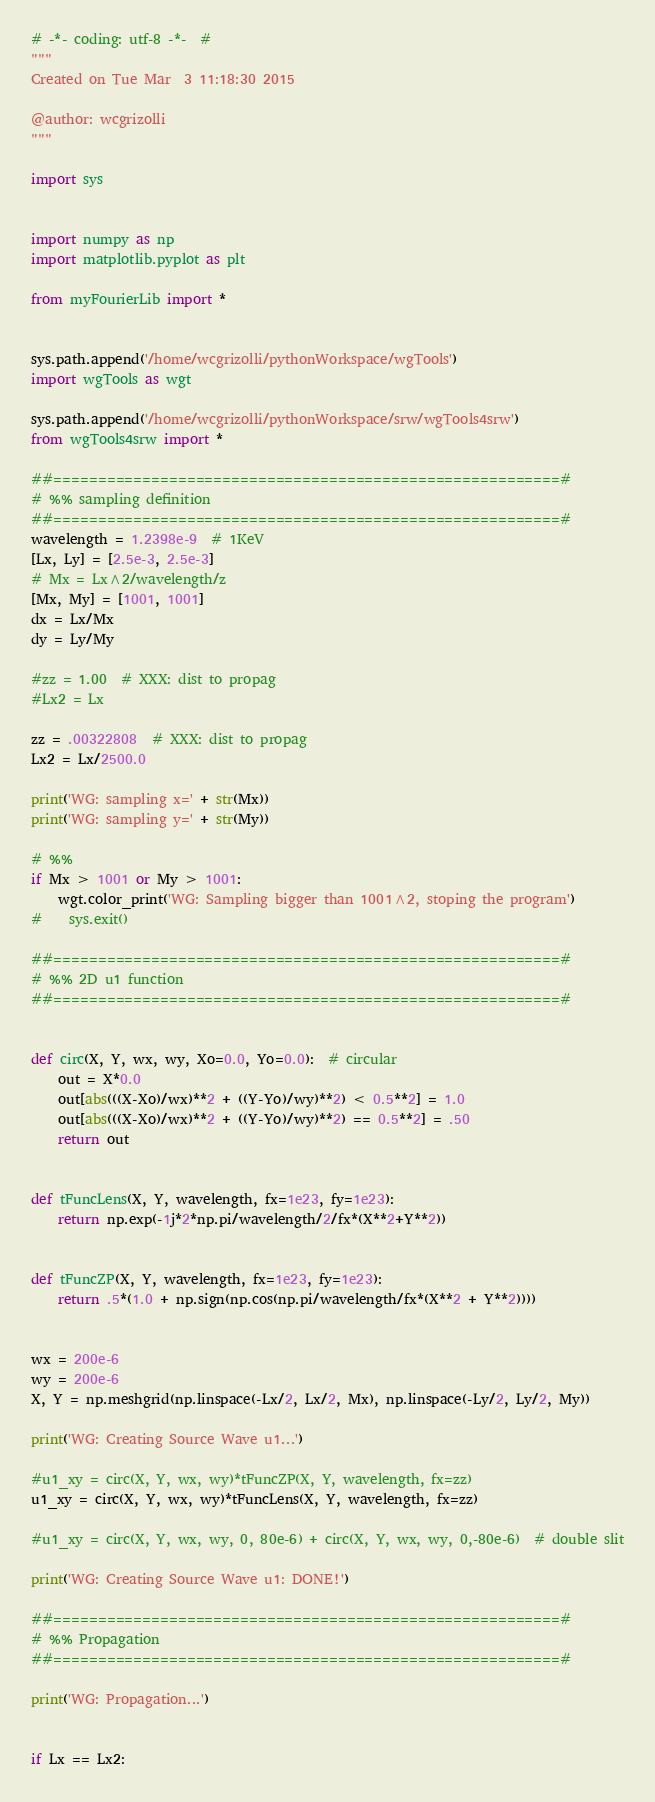<code> <loc_0><loc_0><loc_500><loc_500><_Python_># -*- coding: utf-8 -*-  #
"""
Created on Tue Mar  3 11:18:30 2015

@author: wcgrizolli
"""

import sys


import numpy as np
import matplotlib.pyplot as plt

from myFourierLib import *


sys.path.append('/home/wcgrizolli/pythonWorkspace/wgTools')
import wgTools as wgt

sys.path.append('/home/wcgrizolli/pythonWorkspace/srw/wgTools4srw')
from wgTools4srw import *

##=========================================================#
# %% sampling definition
##=========================================================#
wavelength = 1.2398e-9  # 1KeV
[Lx, Ly] = [2.5e-3, 2.5e-3]
# Mx = Lx^2/wavelength/z
[Mx, My] = [1001, 1001]
dx = Lx/Mx
dy = Ly/My

#zz = 1.00  # XXX: dist to propag
#Lx2 = Lx

zz = .00322808  # XXX: dist to propag
Lx2 = Lx/2500.0

print('WG: sampling x=' + str(Mx))
print('WG: sampling y=' + str(My))

# %%
if Mx > 1001 or My > 1001:
    wgt.color_print('WG: Sampling bigger than 1001^2, stoping the program')
#    sys.exit()

##=========================================================#
# %% 2D u1 function
##=========================================================#


def circ(X, Y, wx, wy, Xo=0.0, Yo=0.0):  # circular
    out = X*0.0
    out[abs(((X-Xo)/wx)**2 + ((Y-Yo)/wy)**2) < 0.5**2] = 1.0
    out[abs(((X-Xo)/wx)**2 + ((Y-Yo)/wy)**2) == 0.5**2] = .50
    return out


def tFuncLens(X, Y, wavelength, fx=1e23, fy=1e23):
    return np.exp(-1j*2*np.pi/wavelength/2/fx*(X**2+Y**2))


def tFuncZP(X, Y, wavelength, fx=1e23, fy=1e23):
    return .5*(1.0 + np.sign(np.cos(np.pi/wavelength/fx*(X**2 + Y**2))))


wx = 200e-6
wy = 200e-6
X, Y = np.meshgrid(np.linspace(-Lx/2, Lx/2, Mx), np.linspace(-Ly/2, Ly/2, My))

print('WG: Creating Source Wave u1...')

#u1_xy = circ(X, Y, wx, wy)*tFuncZP(X, Y, wavelength, fx=zz)
u1_xy = circ(X, Y, wx, wy)*tFuncLens(X, Y, wavelength, fx=zz)

#u1_xy = circ(X, Y, wx, wy, 0, 80e-6) + circ(X, Y, wx, wy, 0,-80e-6)  # double slit

print('WG: Creating Source Wave u1: DONE!')

##=========================================================#
# %% Propagation
##=========================================================#

print('WG: Propagation...')


if Lx == Lx2:</code> 